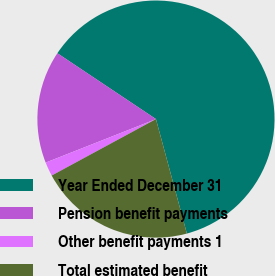<chart> <loc_0><loc_0><loc_500><loc_500><pie_chart><fcel>Year Ended December 31<fcel>Pension benefit payments<fcel>Other benefit payments 1<fcel>Total estimated benefit<nl><fcel>61.43%<fcel>15.35%<fcel>1.92%<fcel>21.3%<nl></chart> 